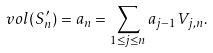<formula> <loc_0><loc_0><loc_500><loc_500>\ v o l ( S _ { n } ^ { \prime } ) = a _ { n } = \sum _ { 1 \leq j \leq n } a _ { j - 1 } V _ { j , n } .</formula> 